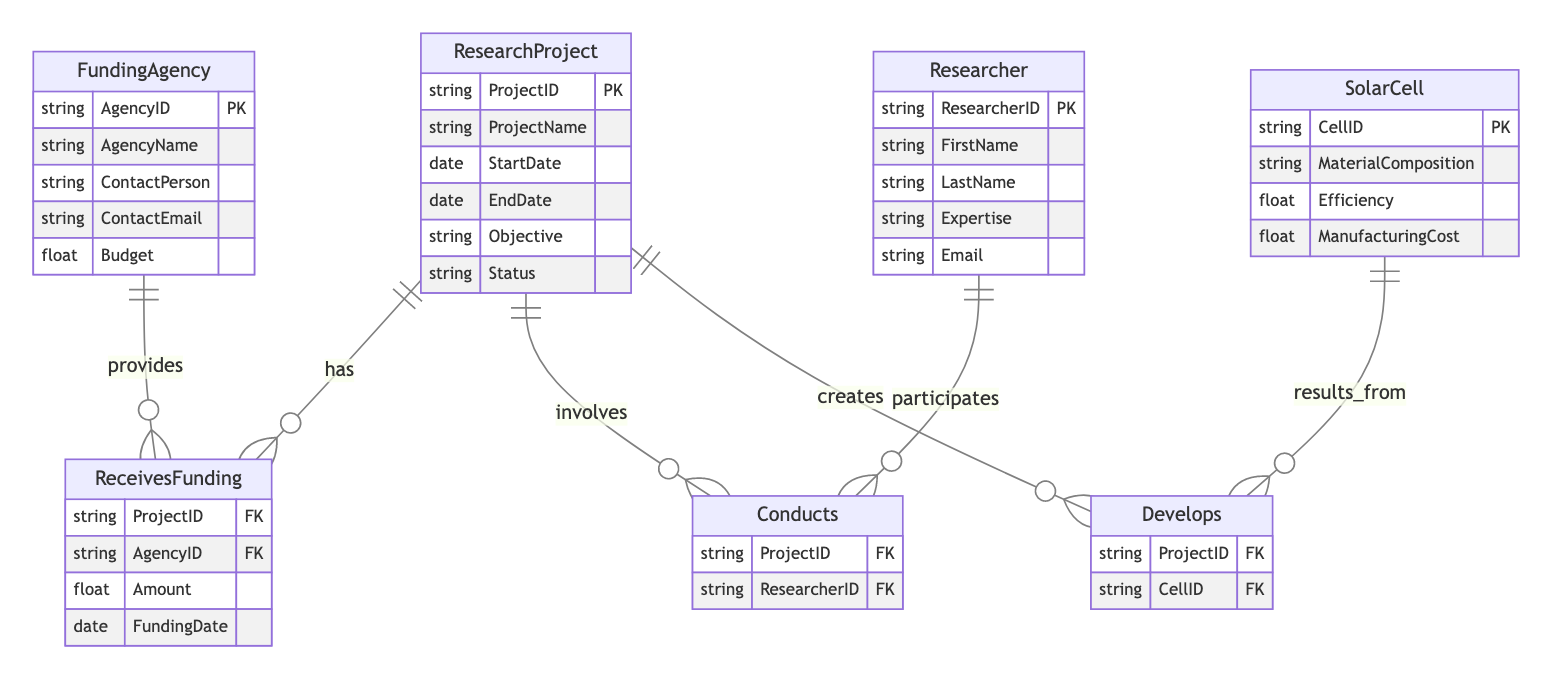What is the primary key for the ResearchProject entity? The primary key for the ResearchProject entity is "ProjectID". This is indicated in the diagram, where "ProjectID" is marked as PK (Primary Key) for that entity.
Answer: ProjectID How many attributes does the FundingAgency entity have? The FundingAgency entity has five attributes: AgencyID, AgencyName, ContactPerson, ContactEmail, and Budget. This can be counted directly from the listed attributes in the diagram.
Answer: 5 What is the relationship type between Researcher and ResearchProject? The relationship between Researcher and ResearchProject is "Conducts". This can be seen in the diagram where the lines connecting these two entities are labeled "Conducts".
Answer: Conducts Which entity is related to SolarCell through the develops relationship? The entity related to SolarCell through the Develops relationship is ResearchProject. This is evident from the diagram structure, where the Develops relationship connects SolarCell and ResearchProject.
Answer: ResearchProject What is the cardinality of the ReceivesFunding relationship? The cardinality of the ReceivesFunding relationship is many-to-one. This means that multiple ResearchProjects can receive funding from a single FundingAgency. This is indicated by the line style in the diagram.
Answer: Many-to-one Which attribute of ResearchProject indicates the completion status of a project? The attribute of ResearchProject that indicates the completion status is "Status". This attribute is listed among those of ResearchProject.
Answer: Status How many foreign keys are in the ReceivesFunding relationship? The ReceivesFunding relationship has two foreign keys, which are ProjectID and AgencyID. This can be seen by the FK designations under the ReceivesFunding relationship in the diagram.
Answer: 2 What is the primary key for the SolarCell entity? The primary key for the SolarCell entity is "CellID". This is specifically noted in the diagram with "CellID" marked as PK.
Answer: CellID Which attribute indicates the expertise of a Researcher? The attribute that indicates the expertise of a Researcher is "Expertise". This is listed as one of the attributes of the Researcher entity in the diagram.
Answer: Expertise 